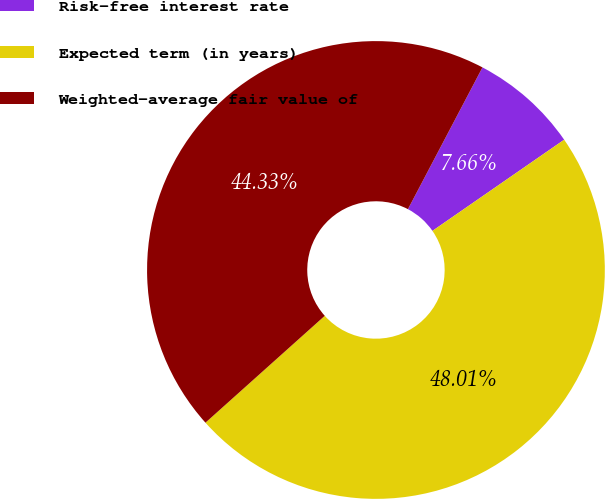<chart> <loc_0><loc_0><loc_500><loc_500><pie_chart><fcel>Risk-free interest rate<fcel>Expected term (in years)<fcel>Weighted-average fair value of<nl><fcel>7.66%<fcel>48.01%<fcel>44.33%<nl></chart> 